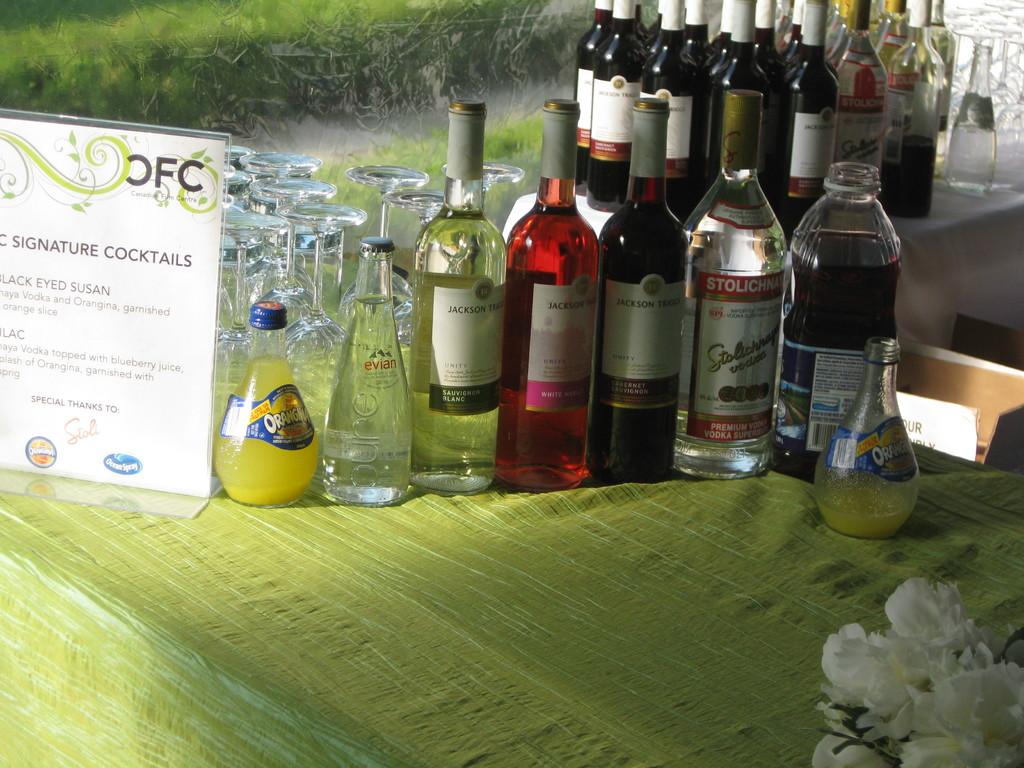These are signature what?
Make the answer very short. Cocktails. What brand of water is in the bottom second from the left?
Give a very brief answer. Evian. 